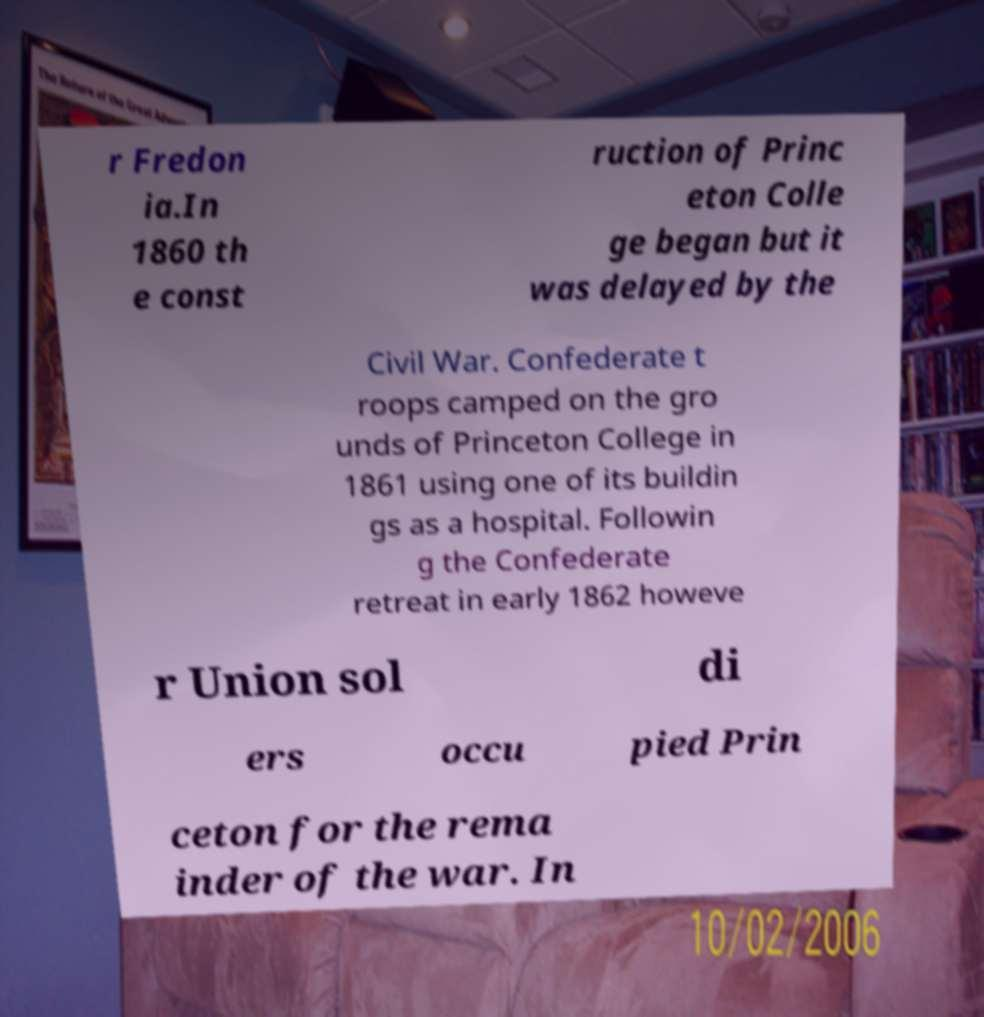Could you extract and type out the text from this image? r Fredon ia.In 1860 th e const ruction of Princ eton Colle ge began but it was delayed by the Civil War. Confederate t roops camped on the gro unds of Princeton College in 1861 using one of its buildin gs as a hospital. Followin g the Confederate retreat in early 1862 howeve r Union sol di ers occu pied Prin ceton for the rema inder of the war. In 